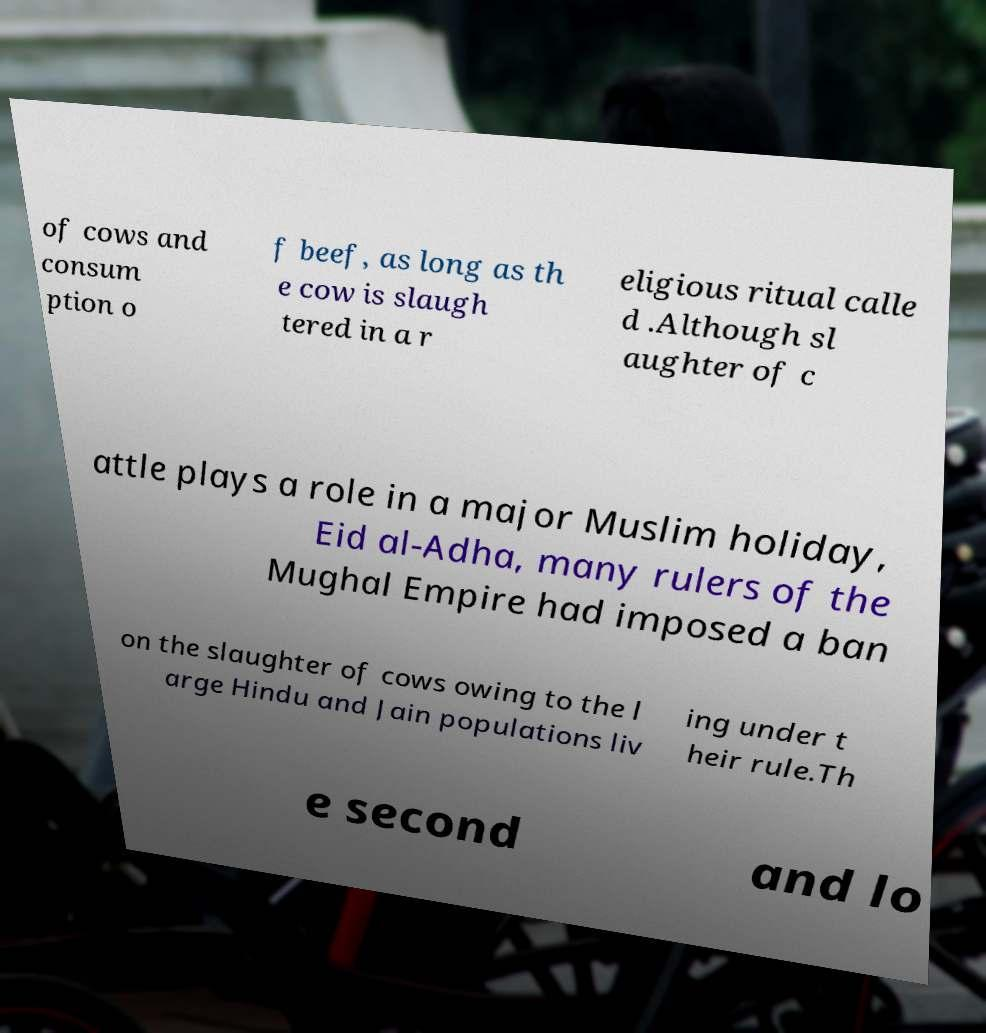Can you accurately transcribe the text from the provided image for me? of cows and consum ption o f beef, as long as th e cow is slaugh tered in a r eligious ritual calle d .Although sl aughter of c attle plays a role in a major Muslim holiday, Eid al-Adha, many rulers of the Mughal Empire had imposed a ban on the slaughter of cows owing to the l arge Hindu and Jain populations liv ing under t heir rule.Th e second and lo 